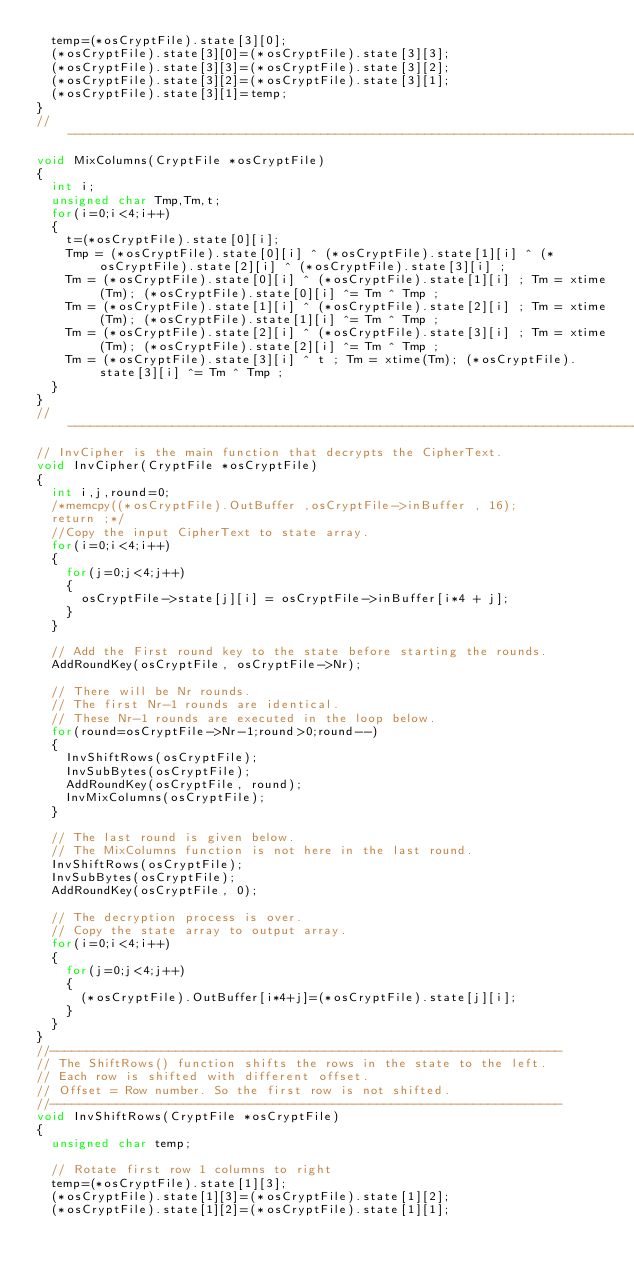<code> <loc_0><loc_0><loc_500><loc_500><_C_>	temp=(*osCryptFile).state[3][0];
	(*osCryptFile).state[3][0]=(*osCryptFile).state[3][3];
	(*osCryptFile).state[3][3]=(*osCryptFile).state[3][2];
	(*osCryptFile).state[3][2]=(*osCryptFile).state[3][1];
	(*osCryptFile).state[3][1]=temp;
}
//-------------------------------------------------------------------------------------------
void MixColumns(CryptFile *osCryptFile)
{
	int i;
	unsigned char Tmp,Tm,t;
	for(i=0;i<4;i++)
	{	
		t=(*osCryptFile).state[0][i];
		Tmp = (*osCryptFile).state[0][i] ^ (*osCryptFile).state[1][i] ^ (*osCryptFile).state[2][i] ^ (*osCryptFile).state[3][i] ;
		Tm = (*osCryptFile).state[0][i] ^ (*osCryptFile).state[1][i] ; Tm = xtime(Tm); (*osCryptFile).state[0][i] ^= Tm ^ Tmp ;
		Tm = (*osCryptFile).state[1][i] ^ (*osCryptFile).state[2][i] ; Tm = xtime(Tm); (*osCryptFile).state[1][i] ^= Tm ^ Tmp ;
		Tm = (*osCryptFile).state[2][i] ^ (*osCryptFile).state[3][i] ; Tm = xtime(Tm); (*osCryptFile).state[2][i] ^= Tm ^ Tmp ;
		Tm = (*osCryptFile).state[3][i] ^ t ; Tm = xtime(Tm); (*osCryptFile).state[3][i] ^= Tm ^ Tmp ;
	}
}
//-------------------------------------------------------------------------------------------
// InvCipher is the main function that decrypts the CipherText.
void InvCipher(CryptFile *osCryptFile)
{
	int i,j,round=0;
	/*memcpy((*osCryptFile).OutBuffer ,osCryptFile->inBuffer , 16);
	return ;*/
	//Copy the input CipherText to state array.
	for(i=0;i<4;i++)
	{
		for(j=0;j<4;j++)
		{
			osCryptFile->state[j][i] = osCryptFile->inBuffer[i*4 + j];
		}
	}

	// Add the First round key to the state before starting the rounds.
	AddRoundKey(osCryptFile, osCryptFile->Nr); 

	// There will be Nr rounds.
	// The first Nr-1 rounds are identical.
	// These Nr-1 rounds are executed in the loop below.
	for(round=osCryptFile->Nr-1;round>0;round--)
	{
		InvShiftRows(osCryptFile);
		InvSubBytes(osCryptFile);
		AddRoundKey(osCryptFile, round);
		InvMixColumns(osCryptFile);
	}

	// The last round is given below.
	// The MixColumns function is not here in the last round.
	InvShiftRows(osCryptFile);
	InvSubBytes(osCryptFile);
	AddRoundKey(osCryptFile, 0);

	// The decryption process is over.
	// Copy the state array to output array.
	for(i=0;i<4;i++)
	{
		for(j=0;j<4;j++)
		{
			(*osCryptFile).OutBuffer[i*4+j]=(*osCryptFile).state[j][i];
		}
	}
}
//---------------------------------------------------------------------
// The ShiftRows() function shifts the rows in the state to the left.
// Each row is shifted with different offset.
// Offset = Row number. So the first row is not shifted.
//---------------------------------------------------------------------
void InvShiftRows(CryptFile *osCryptFile)
{
	unsigned char temp;

	// Rotate first row 1 columns to right	
	temp=(*osCryptFile).state[1][3];
	(*osCryptFile).state[1][3]=(*osCryptFile).state[1][2];
	(*osCryptFile).state[1][2]=(*osCryptFile).state[1][1];</code> 